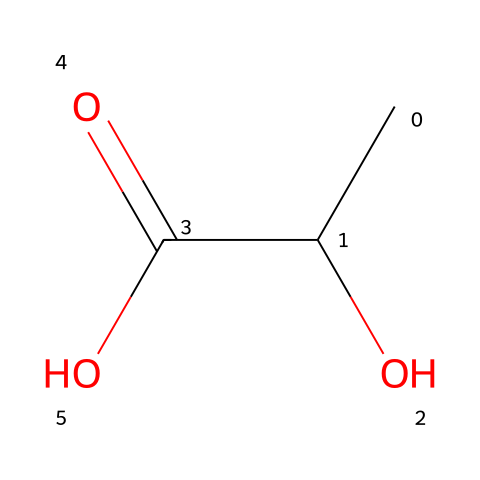What is the name of this chemical? The SMILES representation CC(O)C(=O)O corresponds to lactic acid, which is a common organic acid.
Answer: lactic acid How many carbon atoms are present in this molecule? Analyzing the SMILES, there are three carbon atoms represented in the chain (CC(O)C).
Answer: three What type of functional group is present in this chemical? The structure contains a carboxylic acid group (indicated by C(=O)O), which is a defining characteristic of acids.
Answer: carboxylic acid Does this chemical exhibit stereoisomerism? Since the structure has a chiral carbon (the central carbon with the hydroxyl group), it exhibits stereoisomerism.
Answer: yes What is the pH of a solution containing lactic acid? Lactic acid is a weak acid, typically having a pH in the range of about 3 to 4 when dissolved in water.
Answer: 3 to 4 How many hydrogen atoms are in lactic acid? In the chemical structure, there are six hydrogen atoms accounted for in the molecule (from CC(O)C(=O)O).
Answer: six What effect does lactic acid have on soil in composting initiatives? Lactic acid contributes to soil acidity, promoting microbial activity which is beneficial in composting processes.
Answer: promotes microbial activity 